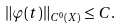<formula> <loc_0><loc_0><loc_500><loc_500>\| \varphi ( t ) \| _ { C ^ { 0 } ( X ) } \leq C .</formula> 